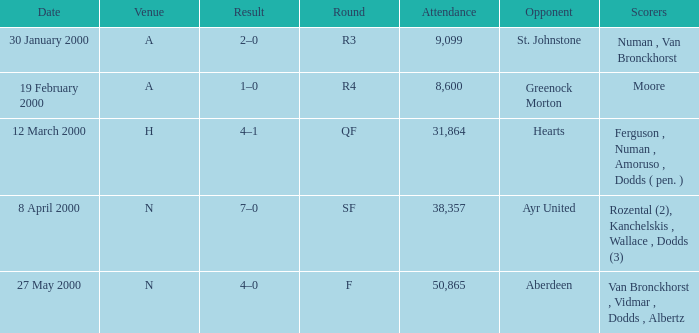Who was on 12 March 2000? Ferguson , Numan , Amoruso , Dodds ( pen. ). 